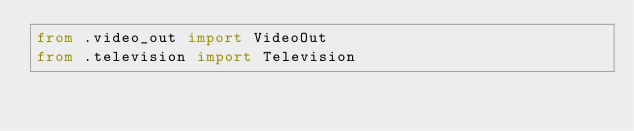<code> <loc_0><loc_0><loc_500><loc_500><_Python_>from .video_out import VideoOut
from .television import Television
</code> 